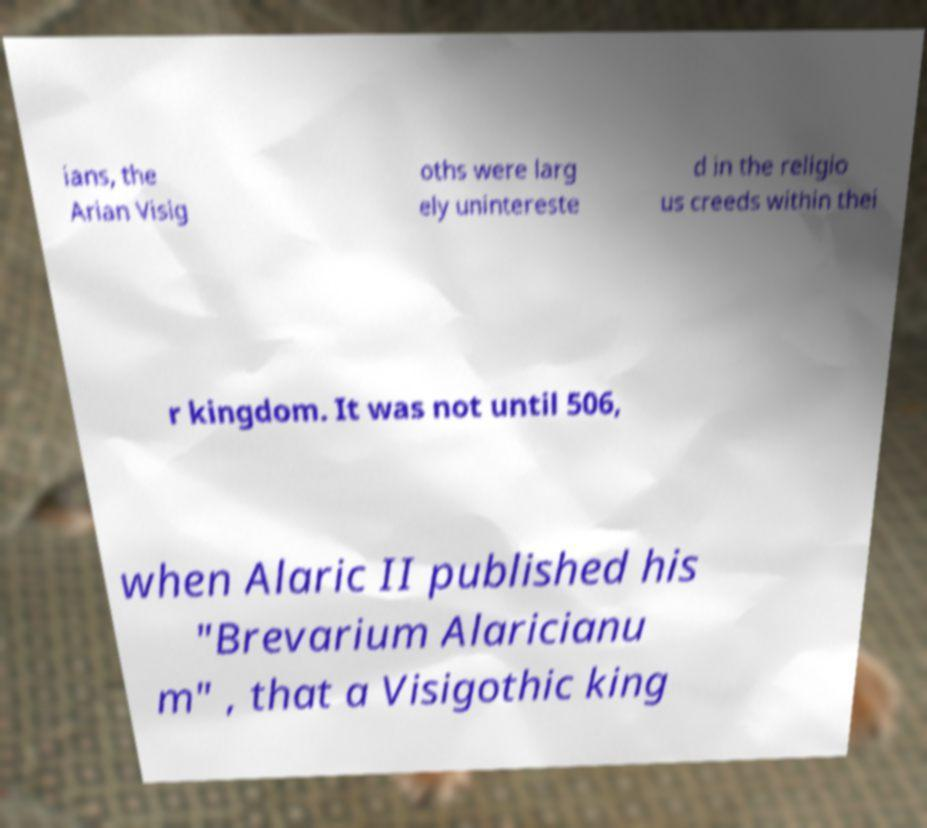Could you assist in decoding the text presented in this image and type it out clearly? ians, the Arian Visig oths were larg ely unintereste d in the religio us creeds within thei r kingdom. It was not until 506, when Alaric II published his "Brevarium Alaricianu m" , that a Visigothic king 